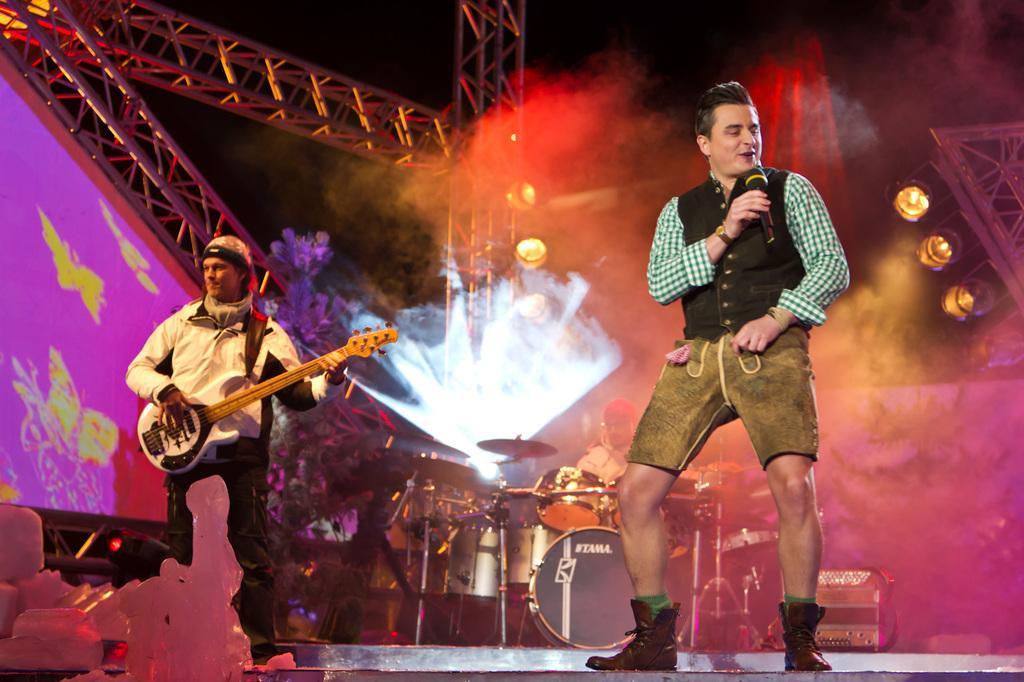Describe this image in one or two sentences. In this image there are two persons standing on a stage. On the right, the person is singing on a mic. On the left the person is playing a guitar. On the left there is a projector looking pink in color. And on the center of the image there is a musical instruments like drum , tramples. On the background there is a person who is playing the musical instruments. On the right there is a lights. 